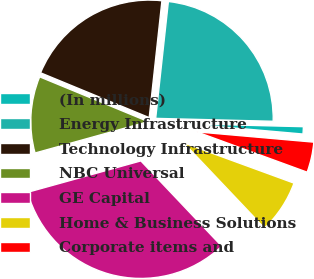Convert chart. <chart><loc_0><loc_0><loc_500><loc_500><pie_chart><fcel>(In millions)<fcel>Energy Infrastructure<fcel>Technology Infrastructure<fcel>NBC Universal<fcel>GE Capital<fcel>Home & Business Solutions<fcel>Corporate items and<nl><fcel>1.0%<fcel>23.67%<fcel>20.5%<fcel>10.53%<fcel>32.77%<fcel>7.35%<fcel>4.18%<nl></chart> 